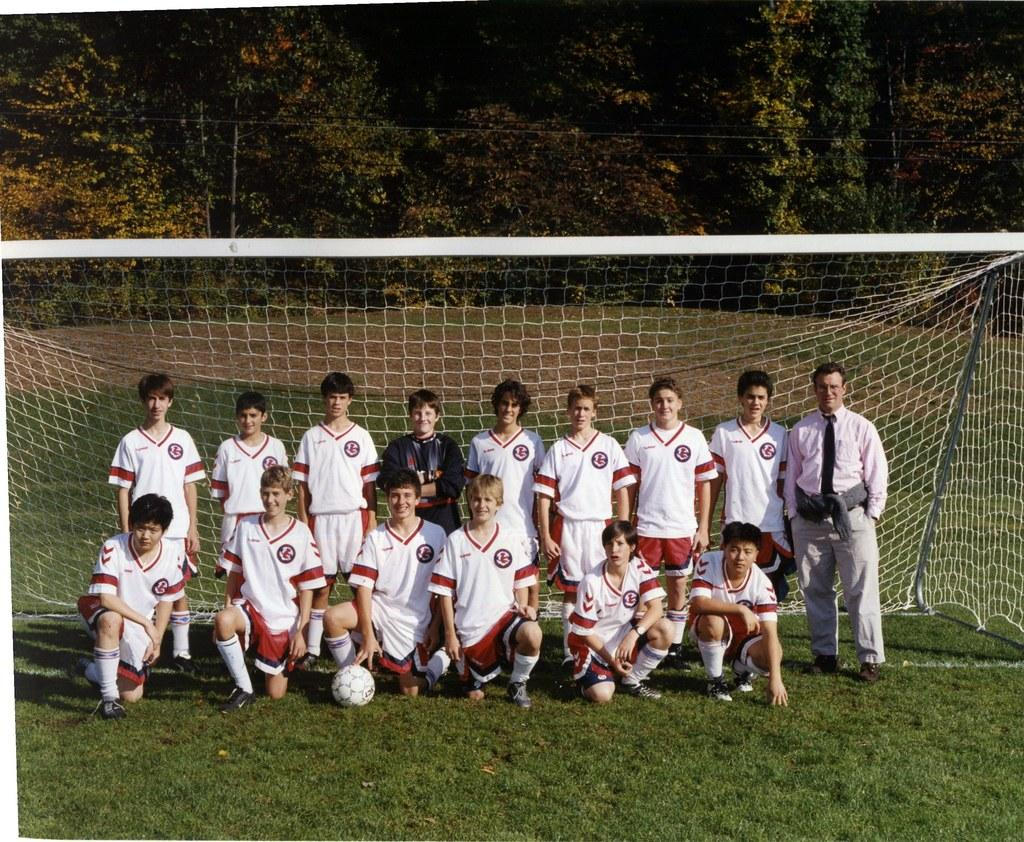Who or what can be seen in the image? There are people in the image. What object is on the grass? There is a ball on the grass. What structure is present in the image? There is a net in the image. What can be seen in the distance in the image? There are trees in the background of the image. What type of card is being used by the people in the image? There is no card present in the image; it features people, a ball, a net, and trees in the background. What company is responsible for the cave in the image? There is no cave present in the image. 